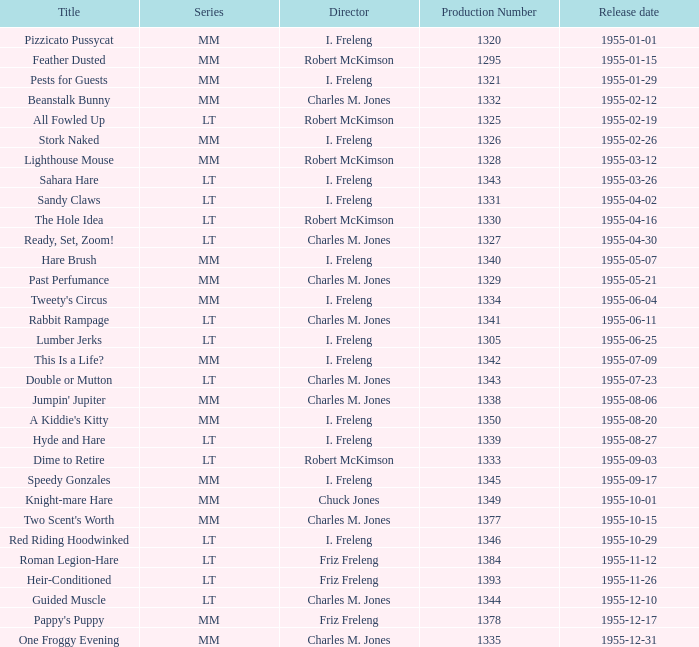What is the title with the production number greater than 1334 released on 1955-08-27? Hyde and Hare. 